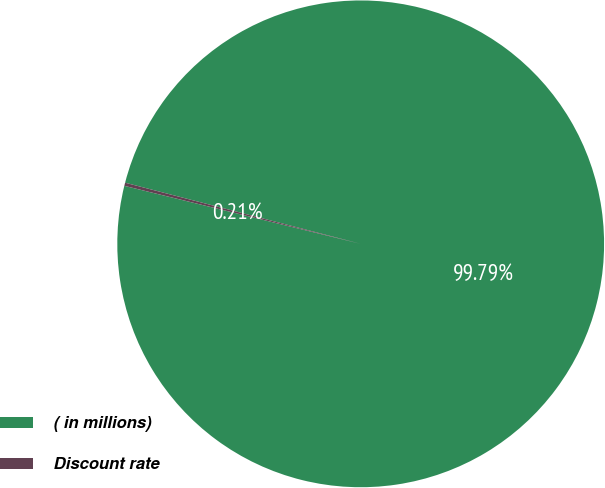Convert chart. <chart><loc_0><loc_0><loc_500><loc_500><pie_chart><fcel>( in millions)<fcel>Discount rate<nl><fcel>99.79%<fcel>0.21%<nl></chart> 